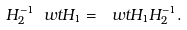Convert formula to latex. <formula><loc_0><loc_0><loc_500><loc_500>H _ { 2 } ^ { - 1 } \ w t H _ { 1 } = \ w t H _ { 1 } H _ { 2 } ^ { - 1 } .</formula> 